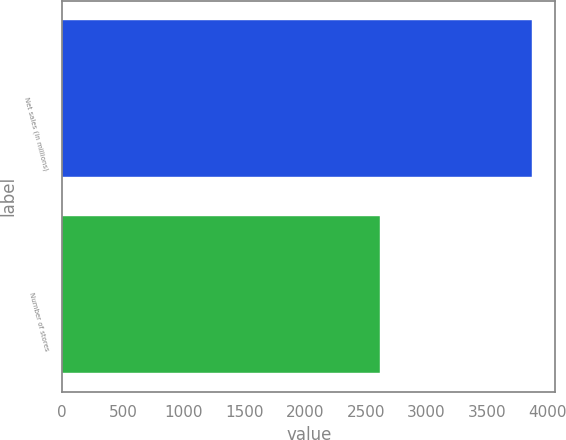Convert chart. <chart><loc_0><loc_0><loc_500><loc_500><bar_chart><fcel>Net sales (in millions)<fcel>Number of stores<nl><fcel>3869.2<fcel>2622<nl></chart> 